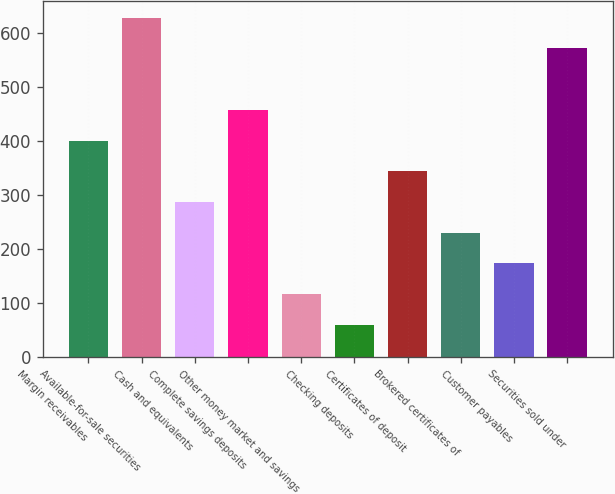<chart> <loc_0><loc_0><loc_500><loc_500><bar_chart><fcel>Margin receivables<fcel>Available-for-sale securities<fcel>Cash and equivalents<fcel>Complete savings deposits<fcel>Other money market and savings<fcel>Checking deposits<fcel>Certificates of deposit<fcel>Brokered certificates of<fcel>Customer payables<fcel>Securities sold under<nl><fcel>401.05<fcel>628.85<fcel>287.15<fcel>458<fcel>116.3<fcel>59.35<fcel>344.1<fcel>230.2<fcel>173.25<fcel>571.9<nl></chart> 